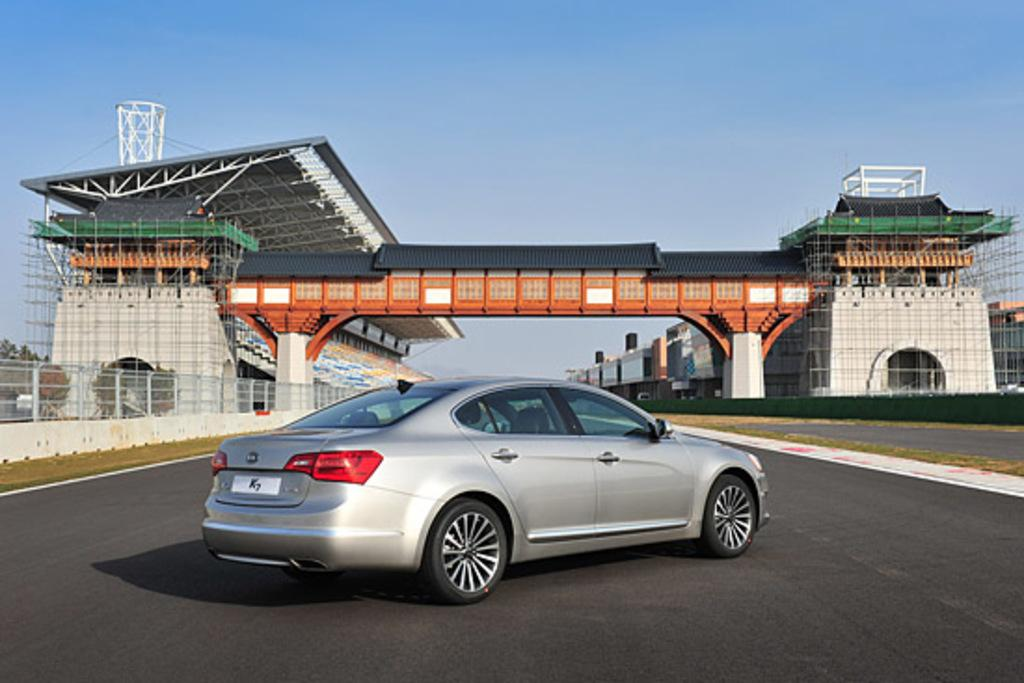What is the main subject of the image? The main subject of the image is a car on the road. What can be seen behind the car in the image? There is a bridge behind the car in the image. What is present on either side of the bridge? There are architectures on either side of the bridge in the image. How many babies are sitting on the car in the image? There are no babies present in the image; it features a car on the road with a bridge and architectures in the background. Can you tell me if the dinosaurs are visible on the bridge in the image? There are no dinosaurs present in the image; it features a car on the road with a bridge and architectures in the background. 